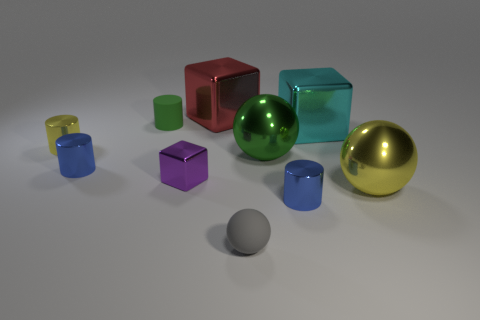There is a blue metal thing to the left of the large object that is on the left side of the gray rubber sphere; is there a large green sphere on the left side of it?
Offer a terse response. No. Is the number of big cyan shiny things on the right side of the tiny rubber cylinder less than the number of cyan blocks on the right side of the big red metallic object?
Give a very brief answer. No. There is another object that is the same material as the small gray object; what color is it?
Provide a succinct answer. Green. What is the color of the matte thing in front of the big metallic cube in front of the green cylinder?
Your answer should be very brief. Gray. Is there a tiny cylinder of the same color as the rubber ball?
Give a very brief answer. No. There is a yellow metallic object that is the same size as the cyan metallic cube; what shape is it?
Give a very brief answer. Sphere. There is a small blue cylinder in front of the big yellow shiny ball; how many tiny purple metal objects are in front of it?
Make the answer very short. 0. Do the small sphere and the matte cylinder have the same color?
Offer a terse response. No. What number of other objects are the same material as the large yellow sphere?
Make the answer very short. 7. What is the shape of the blue metallic object on the right side of the big thing on the left side of the small gray sphere?
Provide a succinct answer. Cylinder. 